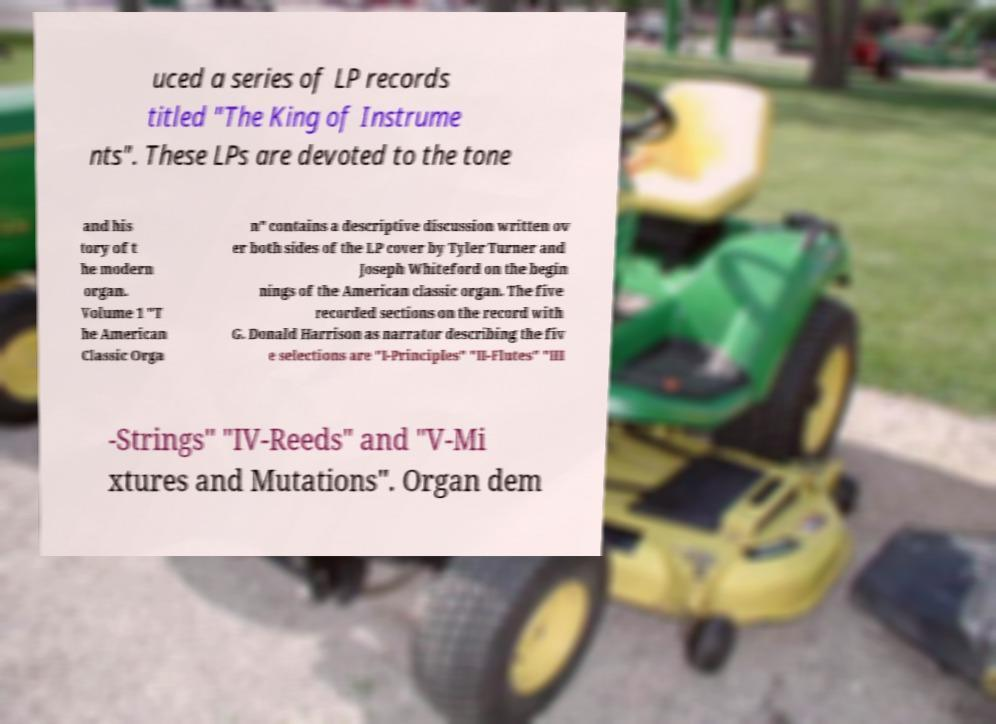For documentation purposes, I need the text within this image transcribed. Could you provide that? uced a series of LP records titled "The King of Instrume nts". These LPs are devoted to the tone and his tory of t he modern organ. Volume 1 "T he American Classic Orga n" contains a descriptive discussion written ov er both sides of the LP cover by Tyler Turner and Joseph Whiteford on the begin nings of the American classic organ. The five recorded sections on the record with G. Donald Harrison as narrator describing the fiv e selections are "I-Principles" "II-Flutes" "III -Strings" "IV-Reeds" and "V-Mi xtures and Mutations". Organ dem 